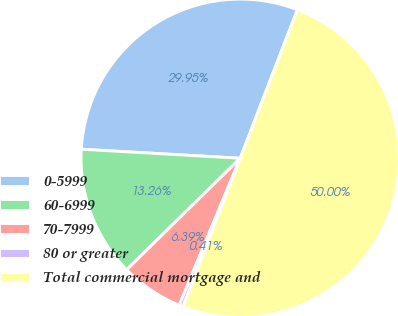Convert chart. <chart><loc_0><loc_0><loc_500><loc_500><pie_chart><fcel>0-5999<fcel>60-6999<fcel>70-7999<fcel>80 or greater<fcel>Total commercial mortgage and<nl><fcel>29.95%<fcel>13.26%<fcel>6.39%<fcel>0.41%<fcel>50.0%<nl></chart> 